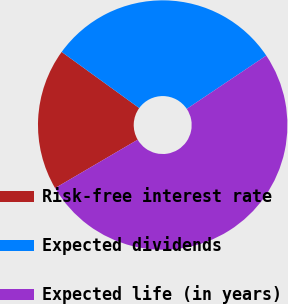Convert chart to OTSL. <chart><loc_0><loc_0><loc_500><loc_500><pie_chart><fcel>Risk-free interest rate<fcel>Expected dividends<fcel>Expected life (in years)<nl><fcel>18.41%<fcel>30.63%<fcel>50.96%<nl></chart> 